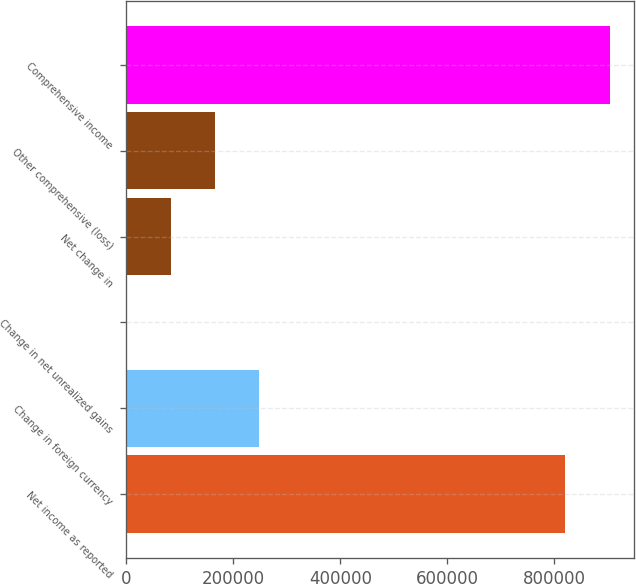<chart> <loc_0><loc_0><loc_500><loc_500><bar_chart><fcel>Net income as reported<fcel>Change in foreign currency<fcel>Change in net unrealized gains<fcel>Net change in<fcel>Other comprehensive (loss)<fcel>Comprehensive income<nl><fcel>820678<fcel>248634<fcel>648<fcel>83310<fcel>165972<fcel>903340<nl></chart> 